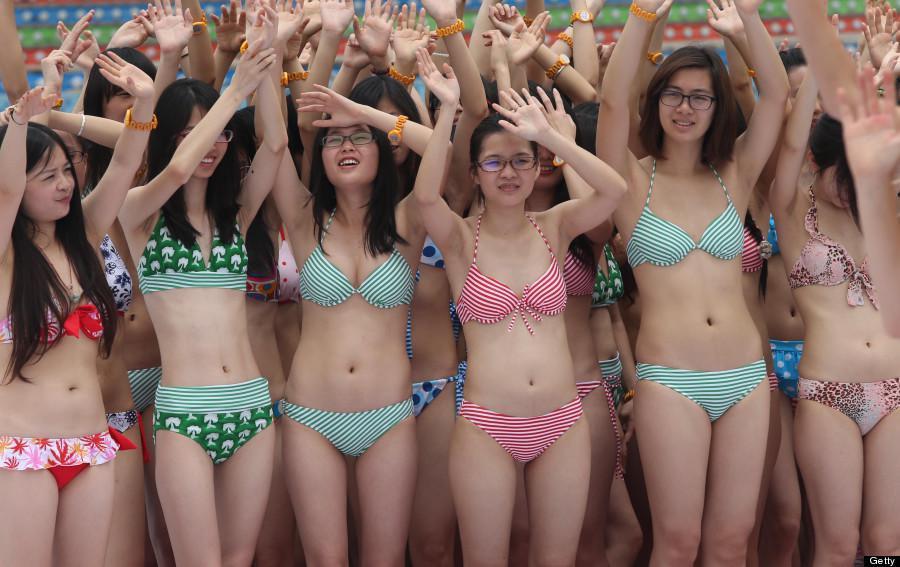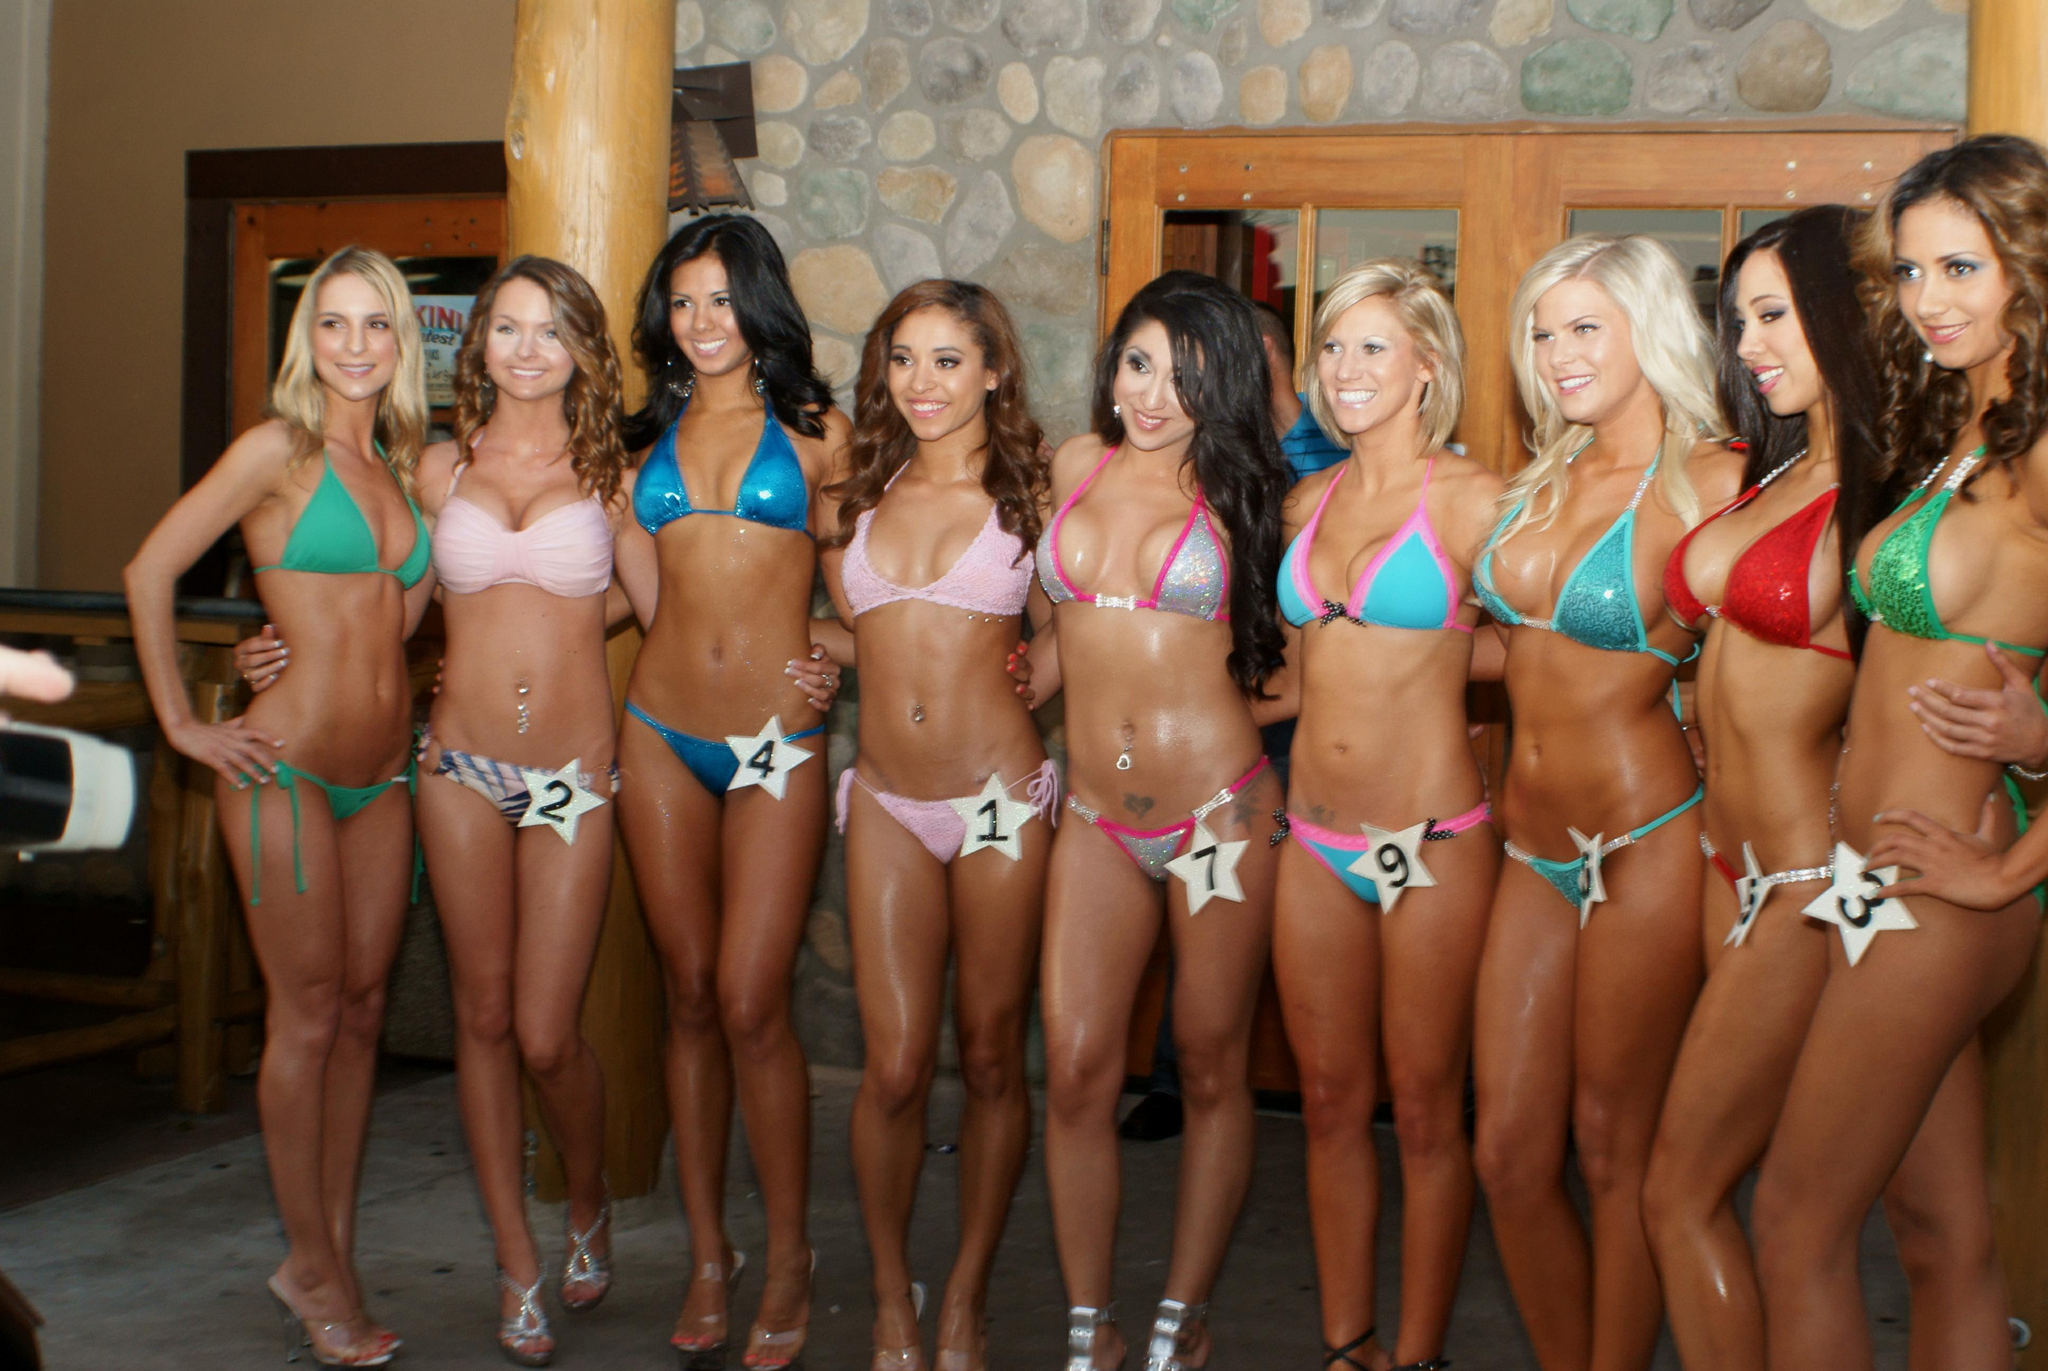The first image is the image on the left, the second image is the image on the right. For the images shown, is this caption "In at least one image there is at least six bodybuilders in bikinis." true? Answer yes or no. Yes. The first image is the image on the left, the second image is the image on the right. Given the left and right images, does the statement "The women in the right image are wearing matching bikinis." hold true? Answer yes or no. No. 